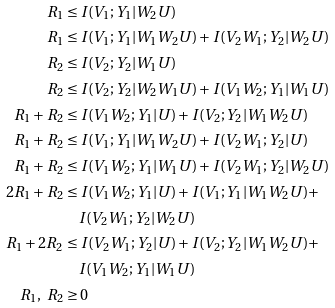<formula> <loc_0><loc_0><loc_500><loc_500>R _ { 1 } & \leq I ( V _ { 1 } ; Y _ { 1 } | W _ { 2 } U ) \\ R _ { 1 } & \leq I ( V _ { 1 } ; Y _ { 1 } | W _ { 1 } W _ { 2 } U ) + I ( V _ { 2 } W _ { 1 } ; Y _ { 2 } | W _ { 2 } U ) \\ R _ { 2 } & \leq I ( V _ { 2 } ; Y _ { 2 } | W _ { 1 } U ) \\ R _ { 2 } & \leq I ( V _ { 2 } ; Y _ { 2 } | W _ { 2 } W _ { 1 } U ) + I ( V _ { 1 } W _ { 2 } ; Y _ { 1 } | W _ { 1 } U ) \\ R _ { 1 } + R _ { 2 } & \leq I ( V _ { 1 } W _ { 2 } ; Y _ { 1 } | U ) + I ( V _ { 2 } ; Y _ { 2 } | W _ { 1 } W _ { 2 } U ) \\ R _ { 1 } + R _ { 2 } & \leq I ( V _ { 1 } ; Y _ { 1 } | W _ { 1 } W _ { 2 } U ) + I ( V _ { 2 } W _ { 1 } ; Y _ { 2 } | U ) \\ R _ { 1 } + R _ { 2 } & \leq I ( V _ { 1 } W _ { 2 } ; Y _ { 1 } | W _ { 1 } U ) + I ( V _ { 2 } W _ { 1 } ; Y _ { 2 } | W _ { 2 } U ) \\ 2 R _ { 1 } + R _ { 2 } & \leq I ( V _ { 1 } W _ { 2 } ; Y _ { 1 } | U ) + I ( V _ { 1 } ; Y _ { 1 } | W _ { 1 } W _ { 2 } U ) + \\ & \quad I ( V _ { 2 } W _ { 1 } ; Y _ { 2 } | W _ { 2 } U ) \\ R _ { 1 } + 2 R _ { 2 } & \leq I ( V _ { 2 } W _ { 1 } ; Y _ { 2 } | U ) + I ( V _ { 2 } ; Y _ { 2 } | W _ { 1 } W _ { 2 } U ) + \\ & \quad I ( V _ { 1 } W _ { 2 } ; Y _ { 1 } | W _ { 1 } U ) \\ R _ { 1 } , \ R _ { 2 } & \geq 0</formula> 